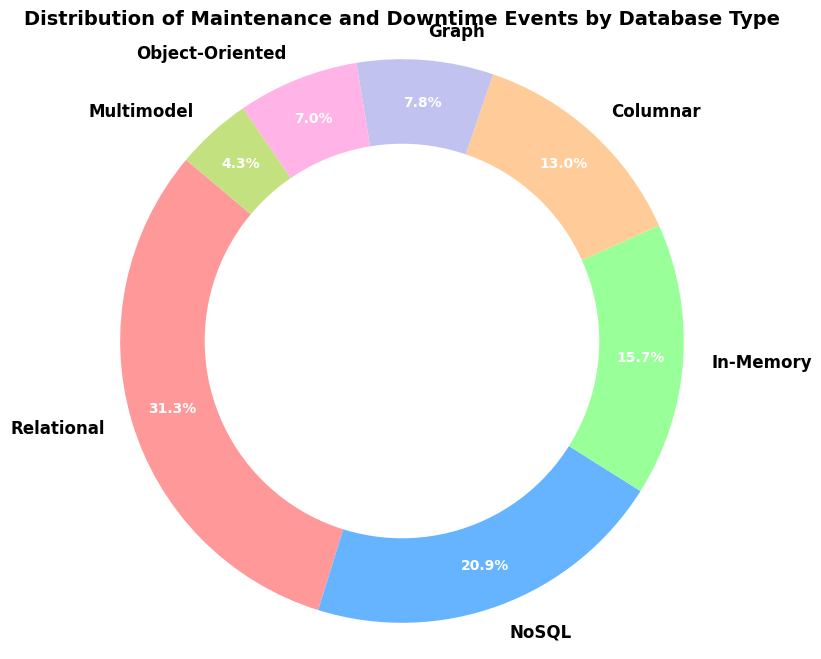What is the most common database type in terms of total events? By looking at the pie chart, we need to identify the largest segment. The largest slice represents the database type with the most combined maintenance and downtime events.
Answer: Relational Which database type has the smallest share of total events? By observing the pie chart, we need to find the smallest segment. The smallest slice indicates the database type with the least total events.
Answer: Multimodel How many more events does the Relational database type have compared to the NoSQL database type? The total events for the Relational database is 180 (150 maintenance + 30 downtime). For NoSQL, it's 120 (100 maintenance + 20 downtime). The difference is 180 - 120 = 60.
Answer: 60 Are there more maintenance events or downtime events for In-Memory databases? From the pie chart segments, In-Memory has 80 maintenance and 10 downtime events. Clearly, there are more maintenance events than downtime events.
Answer: Maintenance events Which two database types combined make up approximately half of the total events? From the pie chart, the largest two segments are Relational (180 events) and NoSQL (120 events). Combined, they are 300 out of 480 total events, which is about 62.5%.
Answer: Relational and NoSQL What proportion of events does the Columnar database type represent? The total number of events for Columnar databases is 75. The overall total is 480 events. The proportion is (75 / 480) * 100 ≈ 15.6%.
Answer: 15.6% How does the total number of events for Graph databases compare to Object-Oriented databases? The pie chart shows that Graph databases have 45 events (40 maintenance + 5 downtime) and Object-Oriented databases have 40 events (30 maintenance + 10 downtime). Graph databases have 5 more events.
Answer: Graph > Object-Oriented If we combine the events for Graph and Multimodel databases, what is their total percentage of events? The Graph database has 45 events, and Multimodel has 25. Together, they have 70 events out of 480 total, giving a percentage of (70 / 480) * 100 ≈ 14.6%.
Answer: 14.6% Which database type has a larger difference between maintenance events and downtime events, Columnar or Object-Oriented? Columnar has 60 maintenance and 15 downtime events, a difference of 45 events. Object-Oriented has 30 maintenance and 10 downtime events, a difference of 20. Therefore, Columnar has the larger difference.
Answer: Columnar Between NoSQL and In-Memory databases, which type has a higher proportion of downtime events relative to their total events? NoSQL has 20 downtime out of 120 total events, around 16.7%. In-Memory has 10 downtime out of 90 total events, about 11.1%. NoSQL has the higher proportion of downtime events.
Answer: NoSQL 